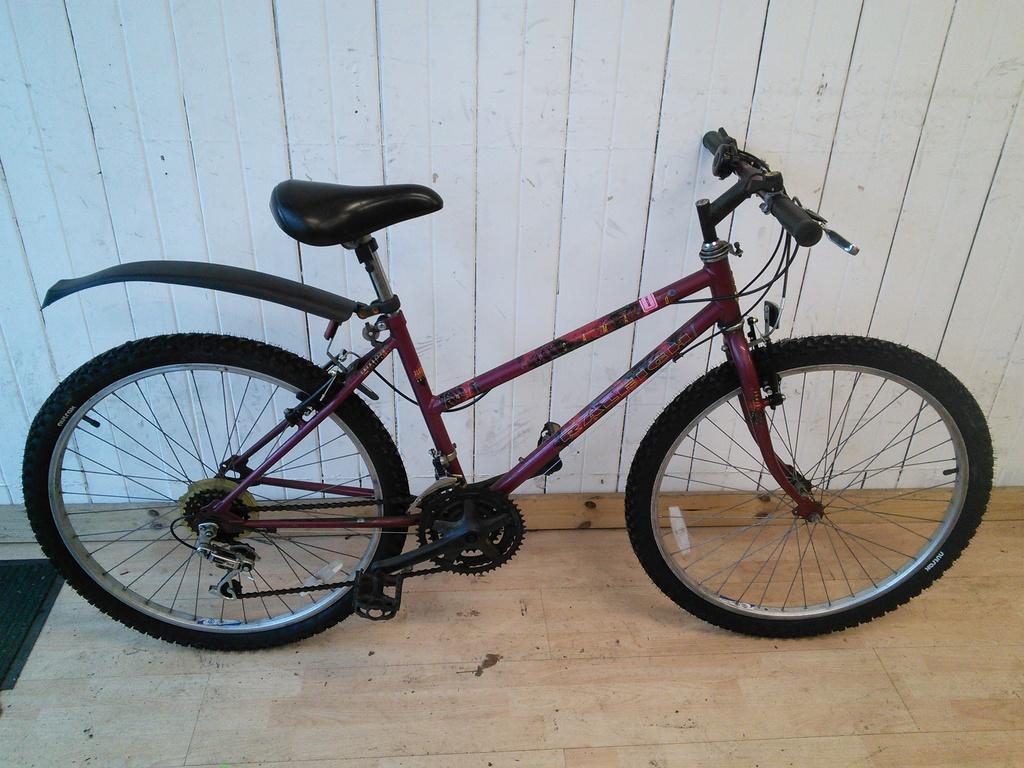What is the main object in the image? There is a cycle in the image. Where is the cycle located? The cycle is parked on a wooden surface. What can be seen in the background of the image? There is a wooden wall in the background of the image. Is there a volcano erupting in the background of the image? No, there is no volcano present in the image. What is the plot of the story being told in the image? The image does not depict a story or have a plot; it is a static representation of a cycle parked on a wooden surface. 